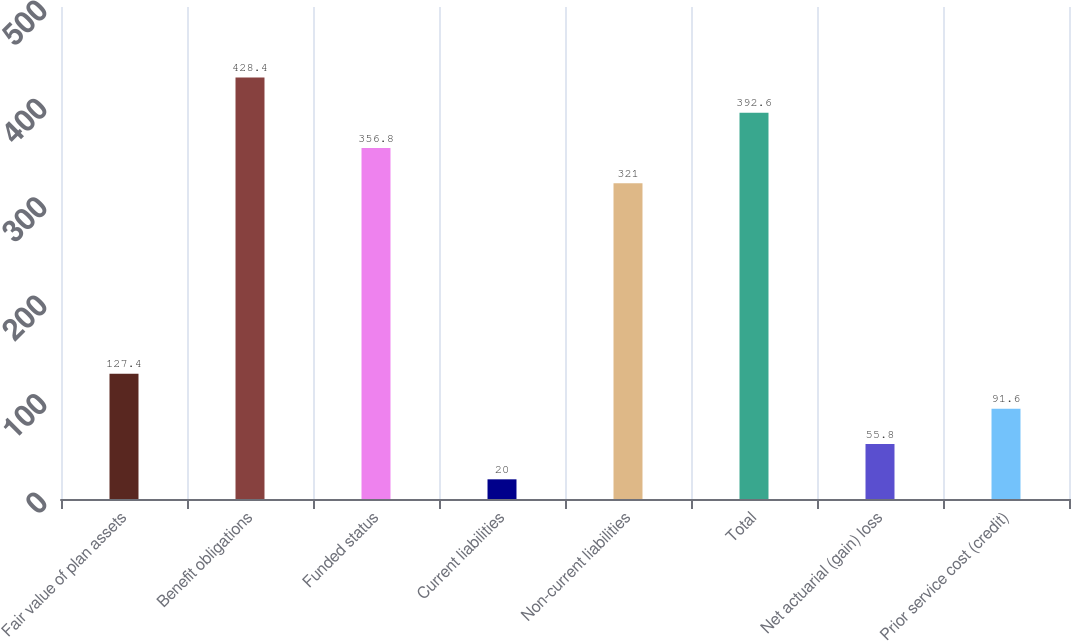Convert chart. <chart><loc_0><loc_0><loc_500><loc_500><bar_chart><fcel>Fair value of plan assets<fcel>Benefit obligations<fcel>Funded status<fcel>Current liabilities<fcel>Non-current liabilities<fcel>Total<fcel>Net actuarial (gain) loss<fcel>Prior service cost (credit)<nl><fcel>127.4<fcel>428.4<fcel>356.8<fcel>20<fcel>321<fcel>392.6<fcel>55.8<fcel>91.6<nl></chart> 